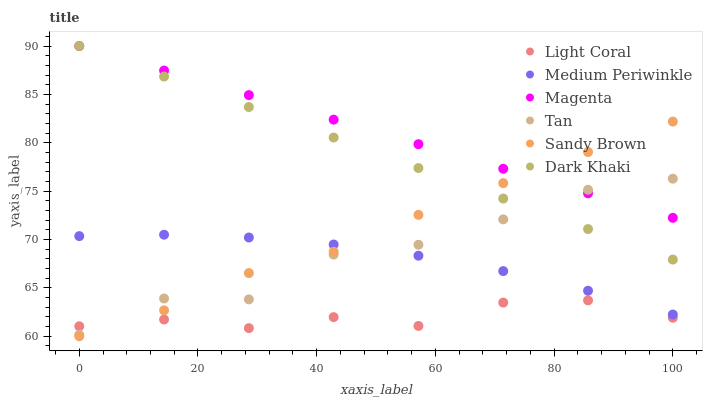Does Light Coral have the minimum area under the curve?
Answer yes or no. Yes. Does Magenta have the maximum area under the curve?
Answer yes or no. Yes. Does Medium Periwinkle have the minimum area under the curve?
Answer yes or no. No. Does Medium Periwinkle have the maximum area under the curve?
Answer yes or no. No. Is Magenta the smoothest?
Answer yes or no. Yes. Is Tan the roughest?
Answer yes or no. Yes. Is Medium Periwinkle the smoothest?
Answer yes or no. No. Is Medium Periwinkle the roughest?
Answer yes or no. No. Does Sandy Brown have the lowest value?
Answer yes or no. Yes. Does Medium Periwinkle have the lowest value?
Answer yes or no. No. Does Magenta have the highest value?
Answer yes or no. Yes. Does Medium Periwinkle have the highest value?
Answer yes or no. No. Is Medium Periwinkle less than Dark Khaki?
Answer yes or no. Yes. Is Dark Khaki greater than Light Coral?
Answer yes or no. Yes. Does Medium Periwinkle intersect Tan?
Answer yes or no. Yes. Is Medium Periwinkle less than Tan?
Answer yes or no. No. Is Medium Periwinkle greater than Tan?
Answer yes or no. No. Does Medium Periwinkle intersect Dark Khaki?
Answer yes or no. No. 